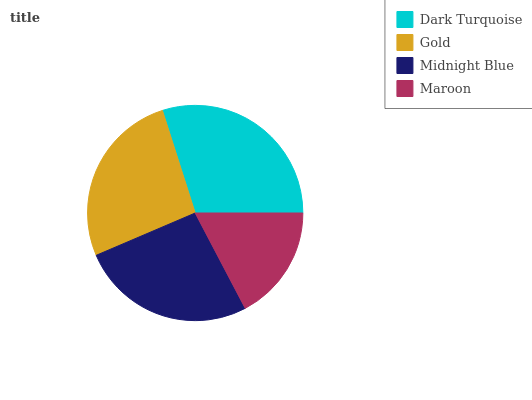Is Maroon the minimum?
Answer yes or no. Yes. Is Dark Turquoise the maximum?
Answer yes or no. Yes. Is Gold the minimum?
Answer yes or no. No. Is Gold the maximum?
Answer yes or no. No. Is Dark Turquoise greater than Gold?
Answer yes or no. Yes. Is Gold less than Dark Turquoise?
Answer yes or no. Yes. Is Gold greater than Dark Turquoise?
Answer yes or no. No. Is Dark Turquoise less than Gold?
Answer yes or no. No. Is Gold the high median?
Answer yes or no. Yes. Is Midnight Blue the low median?
Answer yes or no. Yes. Is Dark Turquoise the high median?
Answer yes or no. No. Is Gold the low median?
Answer yes or no. No. 